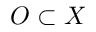<formula> <loc_0><loc_0><loc_500><loc_500>O \subset X</formula> 